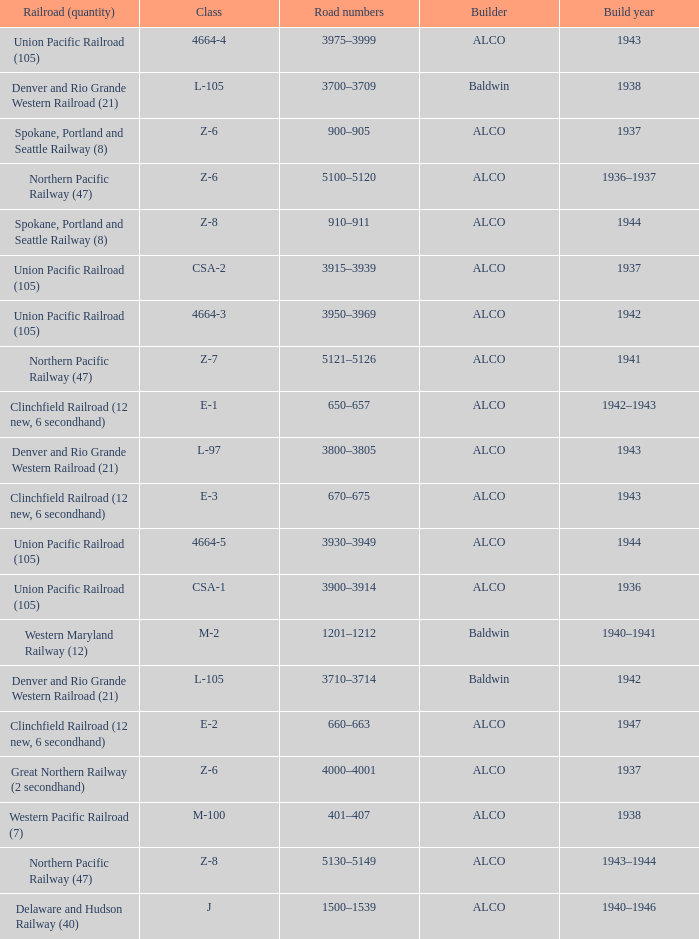What is the road numbers when the class is z-7? 5121–5126. Parse the table in full. {'header': ['Railroad (quantity)', 'Class', 'Road numbers', 'Builder', 'Build year'], 'rows': [['Union Pacific Railroad (105)', '4664-4', '3975–3999', 'ALCO', '1943'], ['Denver and Rio Grande Western Railroad (21)', 'L-105', '3700–3709', 'Baldwin', '1938'], ['Spokane, Portland and Seattle Railway (8)', 'Z-6', '900–905', 'ALCO', '1937'], ['Northern Pacific Railway (47)', 'Z-6', '5100–5120', 'ALCO', '1936–1937'], ['Spokane, Portland and Seattle Railway (8)', 'Z-8', '910–911', 'ALCO', '1944'], ['Union Pacific Railroad (105)', 'CSA-2', '3915–3939', 'ALCO', '1937'], ['Union Pacific Railroad (105)', '4664-3', '3950–3969', 'ALCO', '1942'], ['Northern Pacific Railway (47)', 'Z-7', '5121–5126', 'ALCO', '1941'], ['Clinchfield Railroad (12 new, 6 secondhand)', 'E-1', '650–657', 'ALCO', '1942–1943'], ['Denver and Rio Grande Western Railroad (21)', 'L-97', '3800–3805', 'ALCO', '1943'], ['Clinchfield Railroad (12 new, 6 secondhand)', 'E-3', '670–675', 'ALCO', '1943'], ['Union Pacific Railroad (105)', '4664-5', '3930–3949', 'ALCO', '1944'], ['Union Pacific Railroad (105)', 'CSA-1', '3900–3914', 'ALCO', '1936'], ['Western Maryland Railway (12)', 'M-2', '1201–1212', 'Baldwin', '1940–1941'], ['Denver and Rio Grande Western Railroad (21)', 'L-105', '3710–3714', 'Baldwin', '1942'], ['Clinchfield Railroad (12 new, 6 secondhand)', 'E-2', '660–663', 'ALCO', '1947'], ['Great Northern Railway (2 secondhand)', 'Z-6', '4000–4001', 'ALCO', '1937'], ['Western Pacific Railroad (7)', 'M-100', '401–407', 'ALCO', '1938'], ['Northern Pacific Railway (47)', 'Z-8', '5130–5149', 'ALCO', '1943–1944'], ['Delaware and Hudson Railway (40)', 'J', '1500–1539', 'ALCO', '1940–1946']]} 